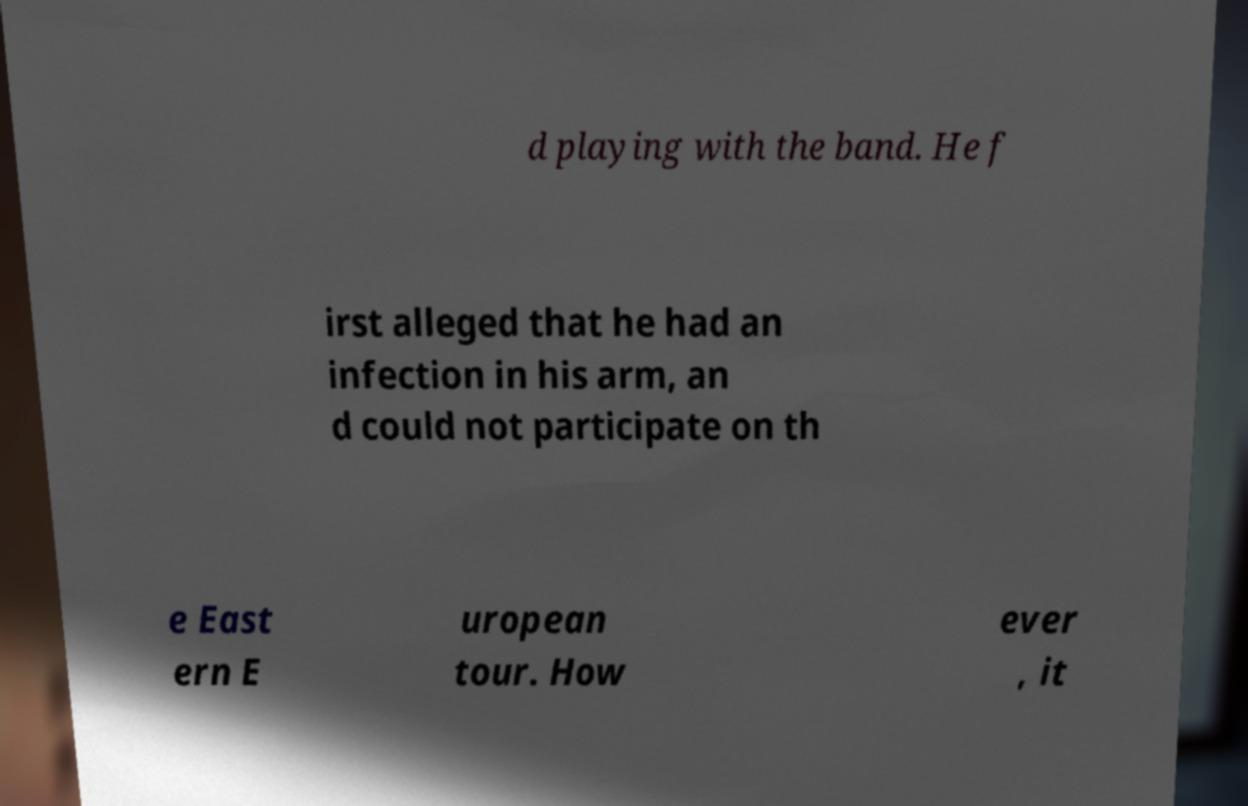What messages or text are displayed in this image? I need them in a readable, typed format. d playing with the band. He f irst alleged that he had an infection in his arm, an d could not participate on th e East ern E uropean tour. How ever , it 